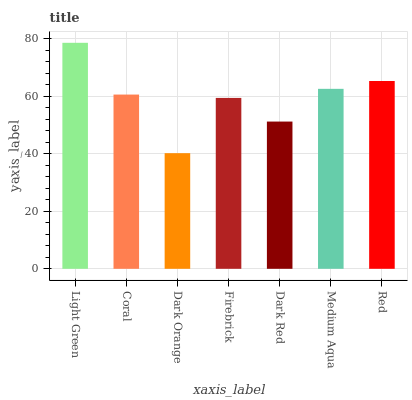Is Dark Orange the minimum?
Answer yes or no. Yes. Is Light Green the maximum?
Answer yes or no. Yes. Is Coral the minimum?
Answer yes or no. No. Is Coral the maximum?
Answer yes or no. No. Is Light Green greater than Coral?
Answer yes or no. Yes. Is Coral less than Light Green?
Answer yes or no. Yes. Is Coral greater than Light Green?
Answer yes or no. No. Is Light Green less than Coral?
Answer yes or no. No. Is Coral the high median?
Answer yes or no. Yes. Is Coral the low median?
Answer yes or no. Yes. Is Medium Aqua the high median?
Answer yes or no. No. Is Light Green the low median?
Answer yes or no. No. 